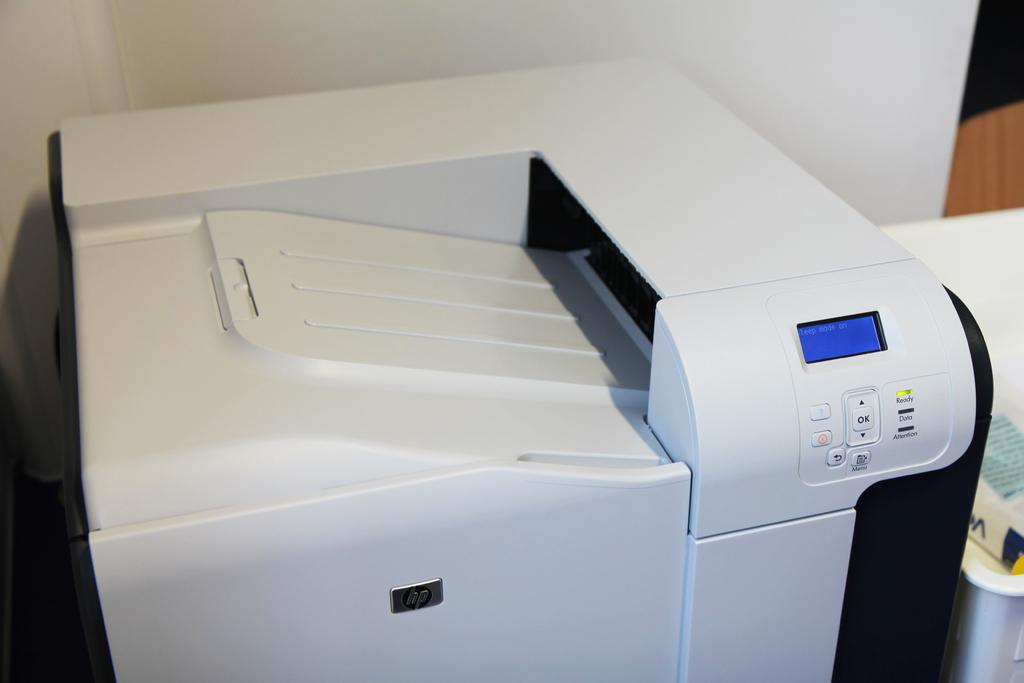<image>
Create a compact narrative representing the image presented. A white HP copier is in sleep mode. 